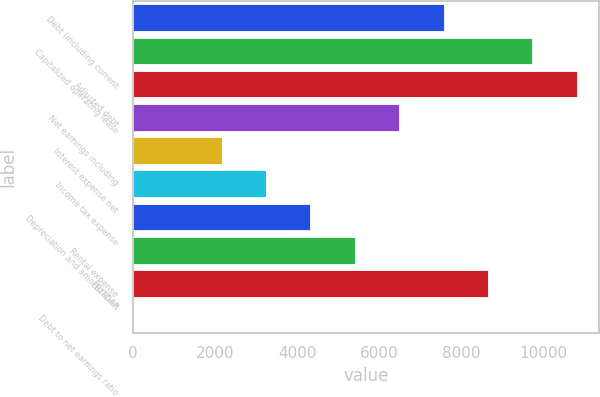Convert chart to OTSL. <chart><loc_0><loc_0><loc_500><loc_500><bar_chart><fcel>Debt (including current<fcel>Capitalized operating lease<fcel>Adjusted debt<fcel>Net earnings including<fcel>Interest expense net<fcel>Income tax expense<fcel>Depreciation and amortization<fcel>Rental expense<fcel>EBITDAR<fcel>Debt to net earnings ratio<nl><fcel>7570.89<fcel>9733.63<fcel>10815<fcel>6489.52<fcel>2164.04<fcel>3245.41<fcel>4326.78<fcel>5408.15<fcel>8652.26<fcel>1.3<nl></chart> 